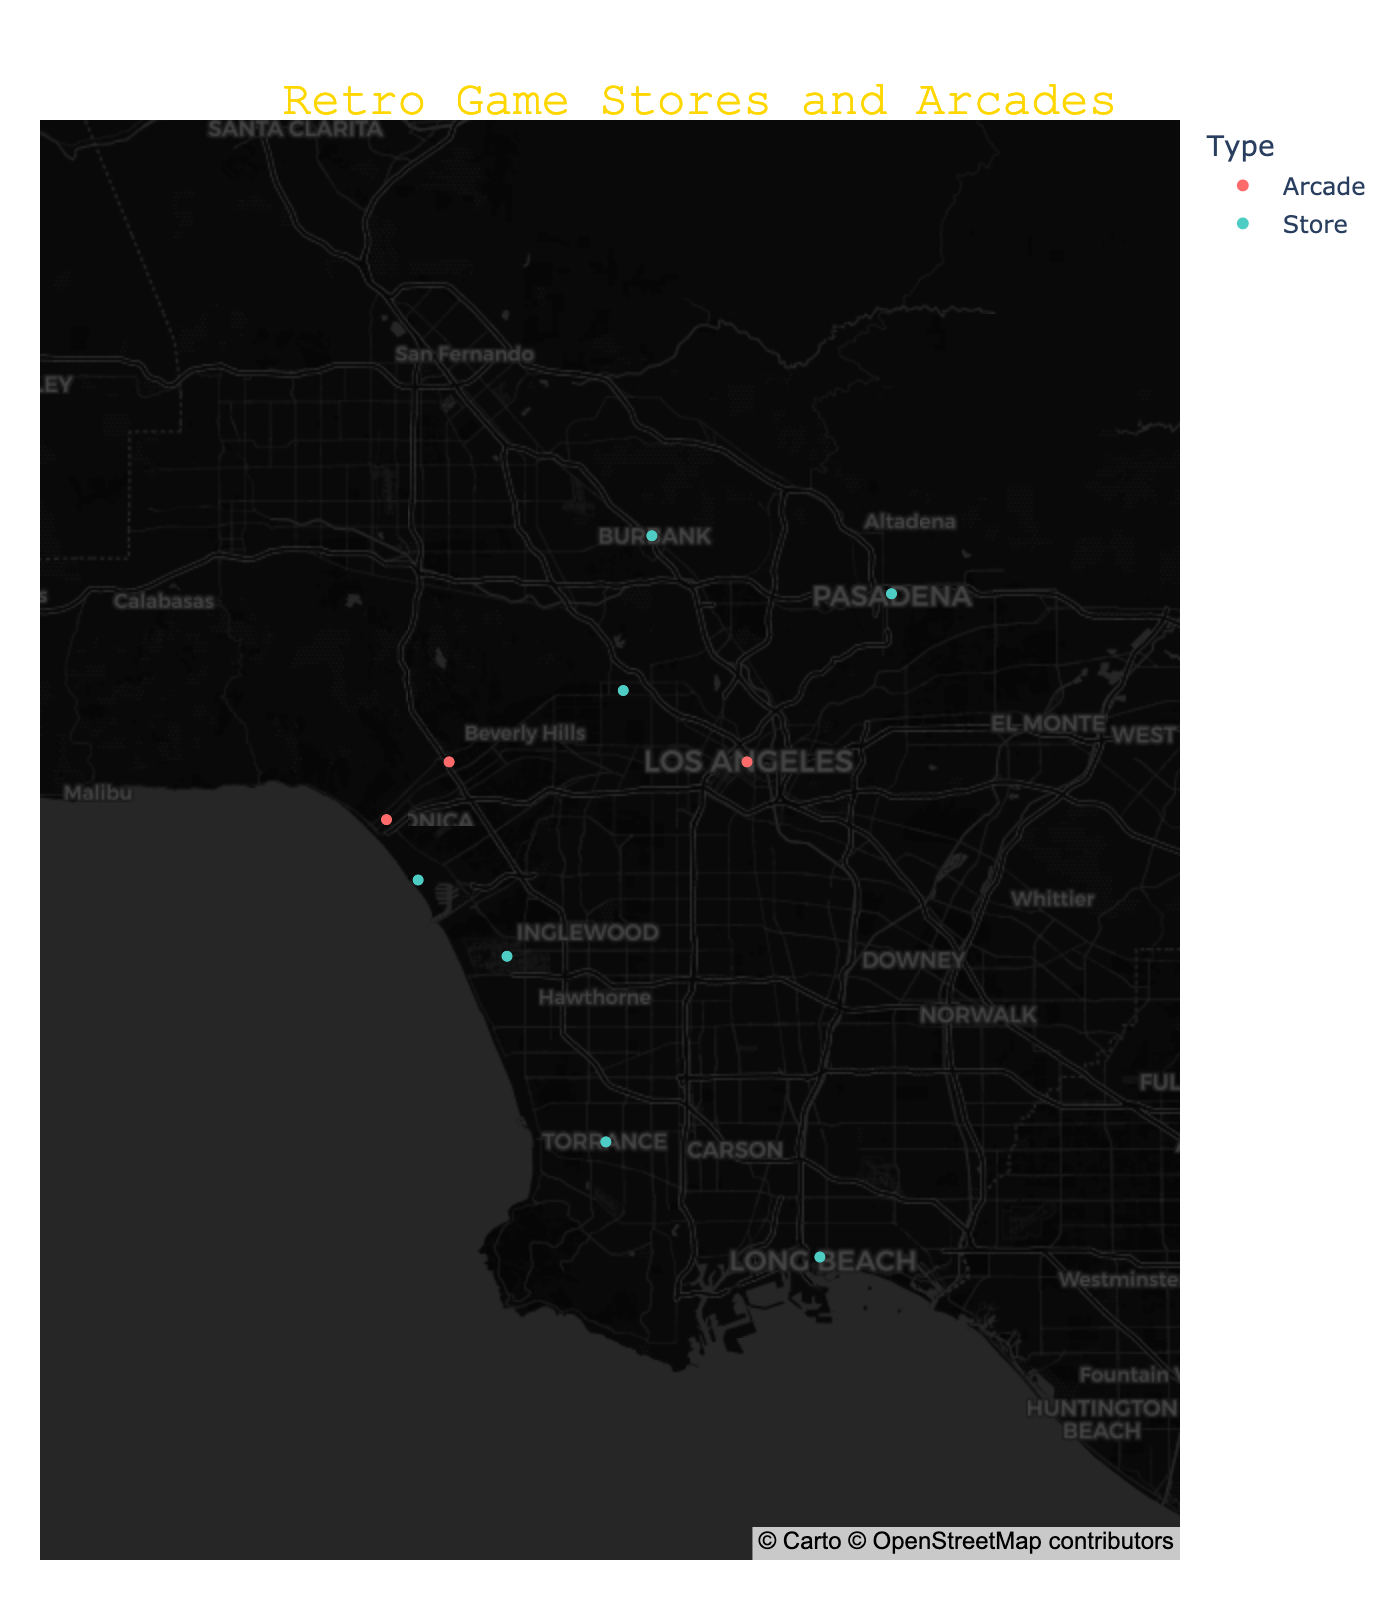What is the title of the figure? The title is located at the top-center of the map and is typically highlighted with a larger font size and a unique color to stand out.
Answer: Retro Game Stores and Arcades How many stores specialize in dog or animal-themed retro games? Look at the specialties mentioned in the hover data for each store and count the ones related to dogs or animals.
Answer: 2 Which store or arcade is closest to the geographical coordinates (34.0522, -118.2437)? Find the marker located at (34.0522, -118.2437) on the map and check the hover data to identify the store name.
Answer: 8-Bit Arcade What is the difference in the number of stores and arcades? Count the markers labeled as "Store" and those labeled as "Arcade" and then find their difference.
Answer: There are 6 stores and 3 arcades, so the difference is 3 Are there more arcades or stores located near the coast? Look at the markers' locations near the edge of the map along the coastline and distinguish between stores and arcades.
Answer: There are more arcades Which store specializes in "Rare and collectible games"? Hover over the markers to read the specialty information and locate the one that mentions "Rare and collectible games".
Answer: Game Over How many arcades feature classic 80s arcade games? Read the hover data for each arcade and tally those with the specialty "Classic 80s arcade games".
Answer: 1 Which arcade is pet-friendly? Hover over the arcade markers and read the specialty information to find the pet-friendly one.
Answer: Bark & Play Between Retro Game Haven and Bits & Bytes, which one is located further east? Compare the longitude values of Retro Game Haven (34.1478, -118.1445) and Bits & Bytes (34.1808, -118.3090). Higher negative longitude means further west.
Answer: Retro Game Haven 